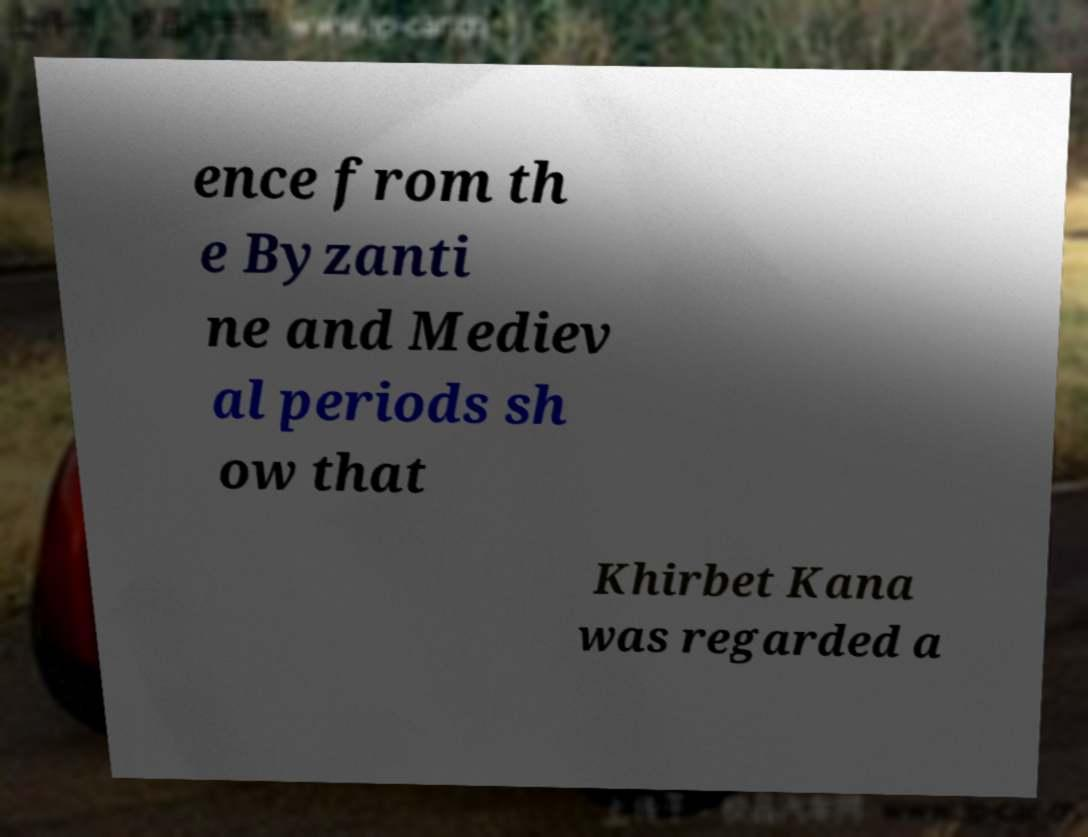Could you extract and type out the text from this image? ence from th e Byzanti ne and Mediev al periods sh ow that Khirbet Kana was regarded a 